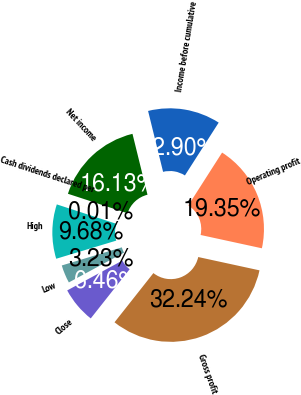Convert chart. <chart><loc_0><loc_0><loc_500><loc_500><pie_chart><fcel>Gross profit<fcel>Operating profit<fcel>Income before cumulative<fcel>Net income<fcel>Cash dividends declared per<fcel>High<fcel>Low<fcel>Close<nl><fcel>32.24%<fcel>19.35%<fcel>12.9%<fcel>16.13%<fcel>0.01%<fcel>9.68%<fcel>3.23%<fcel>6.46%<nl></chart> 